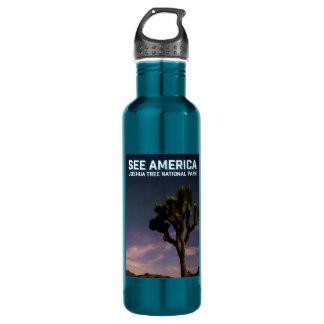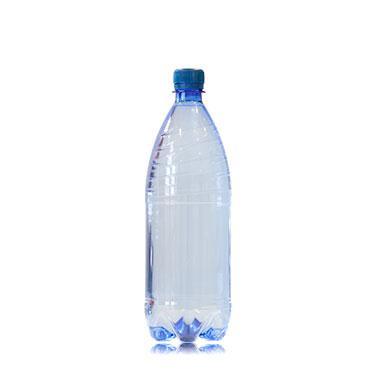The first image is the image on the left, the second image is the image on the right. Analyze the images presented: Is the assertion "An image shows at least one opaque robin's-egg blue water bottle with a silver cap on it." valid? Answer yes or no. No. The first image is the image on the left, the second image is the image on the right. Analyze the images presented: Is the assertion "One image shows at least one teal colored stainless steel water bottle with a silver chrome cap" valid? Answer yes or no. No. 